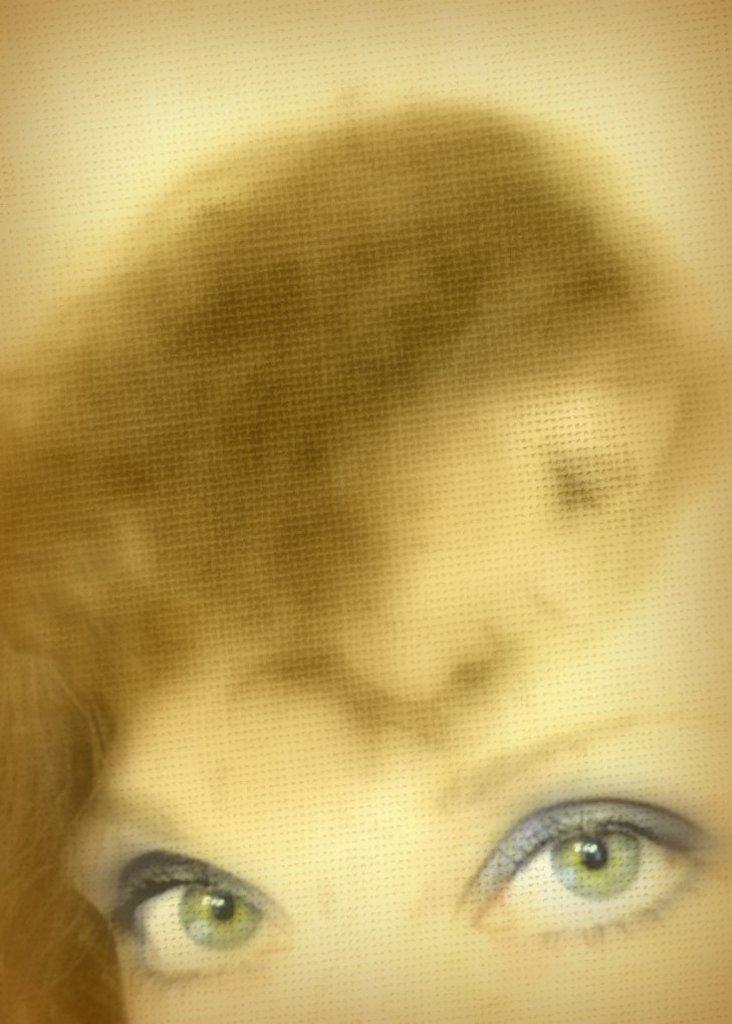How many animated characters are present in the image? There are two animated characters in the image. What type of plants can be seen growing on the muscles of the animated characters in the image? There is no mention of muscles or plants in the image; it only states that there are two animated characters present. 